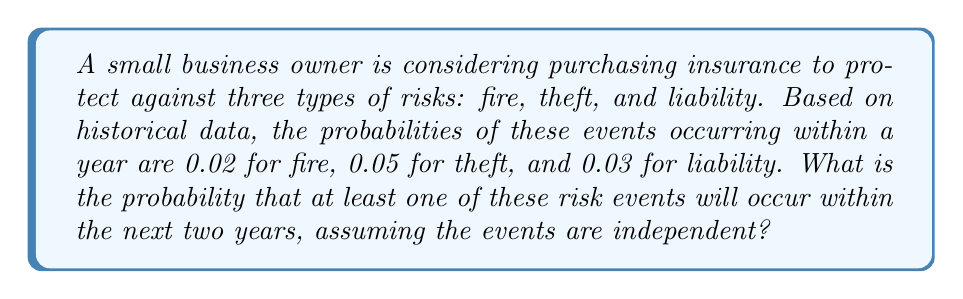Can you solve this math problem? Let's approach this step-by-step:

1) First, we need to calculate the probability of each event occurring within two years. Since we're given annual probabilities, we can use the complement method:

   For fire: $P(\text{fire in 2 years}) = 1 - (1-0.02)^2 = 1 - 0.98^2 = 0.0396$
   For theft: $P(\text{theft in 2 years}) = 1 - (1-0.05)^2 = 1 - 0.95^2 = 0.0975$
   For liability: $P(\text{liability in 2 years}) = 1 - (1-0.03)^2 = 1 - 0.97^2 = 0.0591$

2) Now, we want to find the probability of at least one of these events occurring. It's easier to calculate the probability of none of them occurring and then subtract from 1.

3) The probability of none of these events occurring in two years is the product of the probabilities of each event not occurring:

   $P(\text{none}) = (1-0.0396)(1-0.0975)(1-0.0591) = 0.9604 \times 0.9025 \times 0.9409 = 0.8161$

4) Therefore, the probability of at least one event occurring is:

   $P(\text{at least one}) = 1 - P(\text{none}) = 1 - 0.8161 = 0.1839$
Answer: 0.1839 